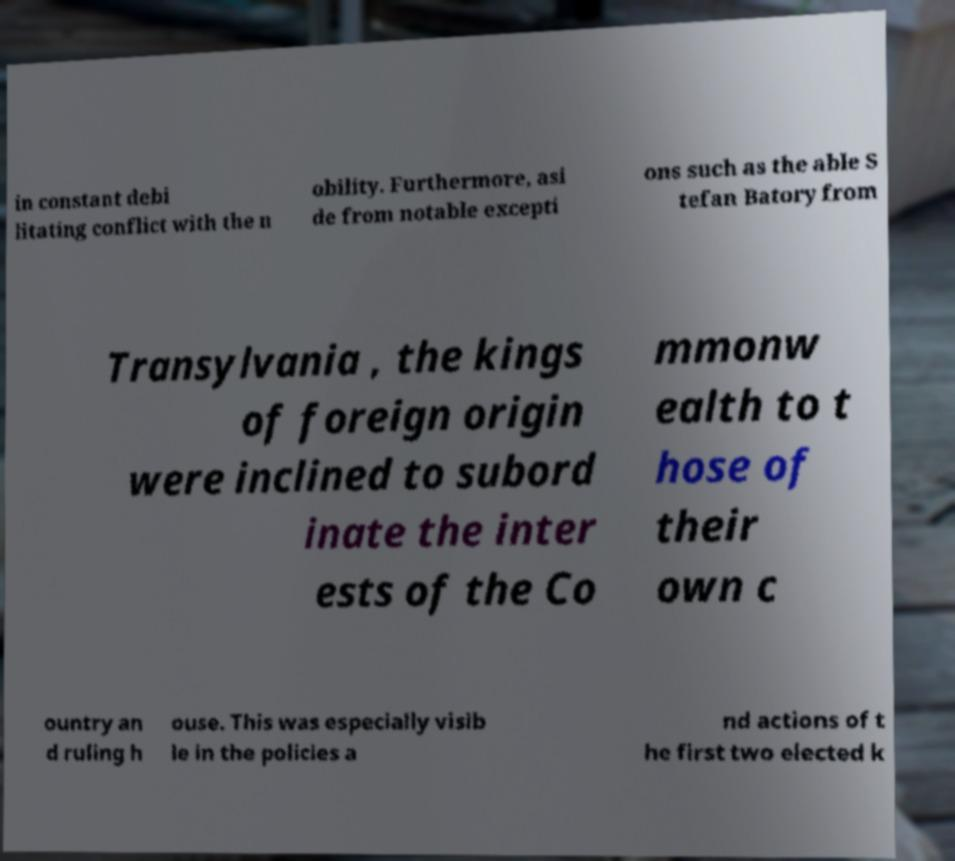Could you extract and type out the text from this image? in constant debi litating conflict with the n obility. Furthermore, asi de from notable excepti ons such as the able S tefan Batory from Transylvania , the kings of foreign origin were inclined to subord inate the inter ests of the Co mmonw ealth to t hose of their own c ountry an d ruling h ouse. This was especially visib le in the policies a nd actions of t he first two elected k 